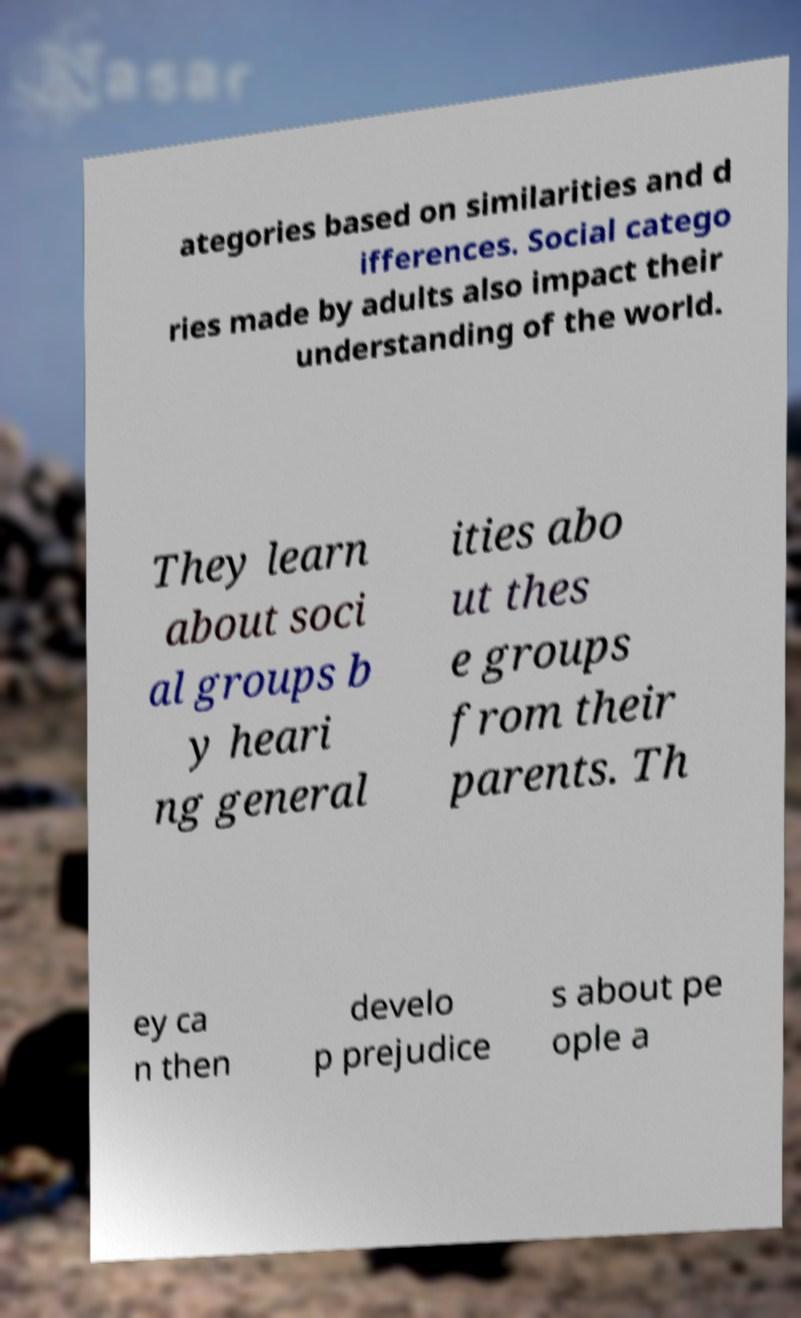Could you extract and type out the text from this image? ategories based on similarities and d ifferences. Social catego ries made by adults also impact their understanding of the world. They learn about soci al groups b y heari ng general ities abo ut thes e groups from their parents. Th ey ca n then develo p prejudice s about pe ople a 